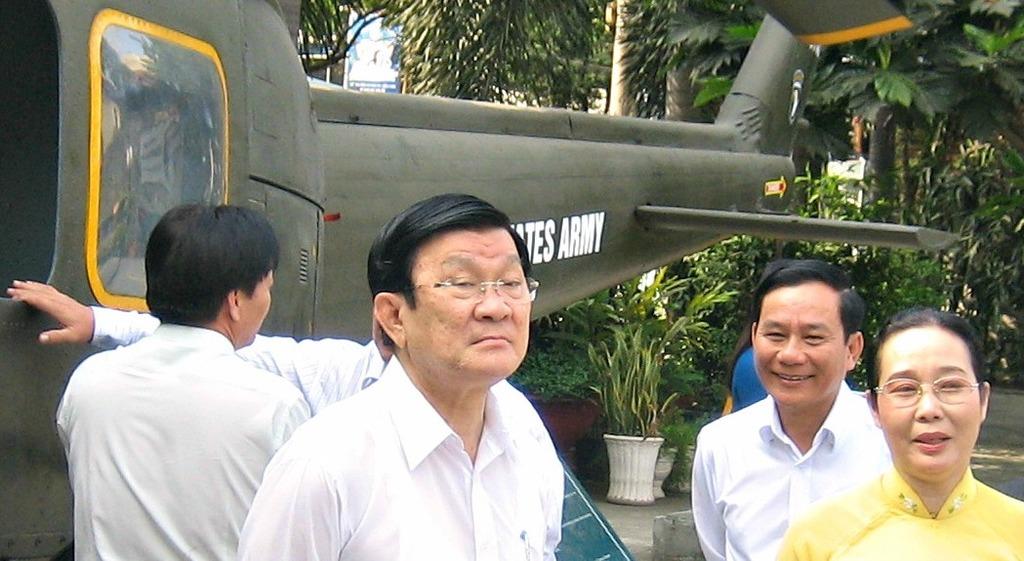What is the visible word on the airplane?
Ensure brevity in your answer.  Army. 